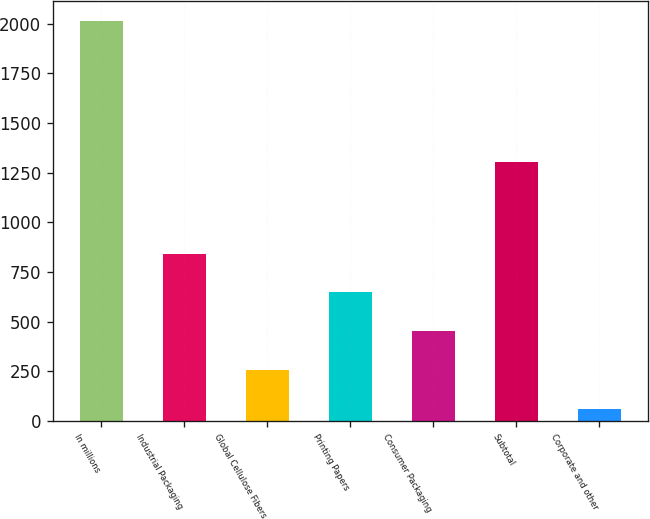Convert chart. <chart><loc_0><loc_0><loc_500><loc_500><bar_chart><fcel>In millions<fcel>Industrial Packaging<fcel>Global Cellulose Fibers<fcel>Printing Papers<fcel>Consumer Packaging<fcel>Subtotal<fcel>Corporate and other<nl><fcel>2014<fcel>842.2<fcel>256.3<fcel>646.9<fcel>451.6<fcel>1305<fcel>61<nl></chart> 